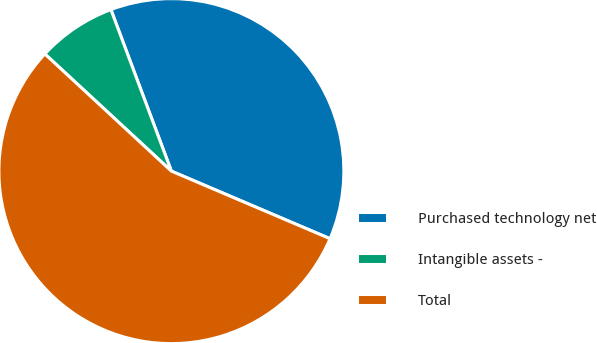Convert chart to OTSL. <chart><loc_0><loc_0><loc_500><loc_500><pie_chart><fcel>Purchased technology net<fcel>Intangible assets -<fcel>Total<nl><fcel>37.11%<fcel>7.41%<fcel>55.48%<nl></chart> 